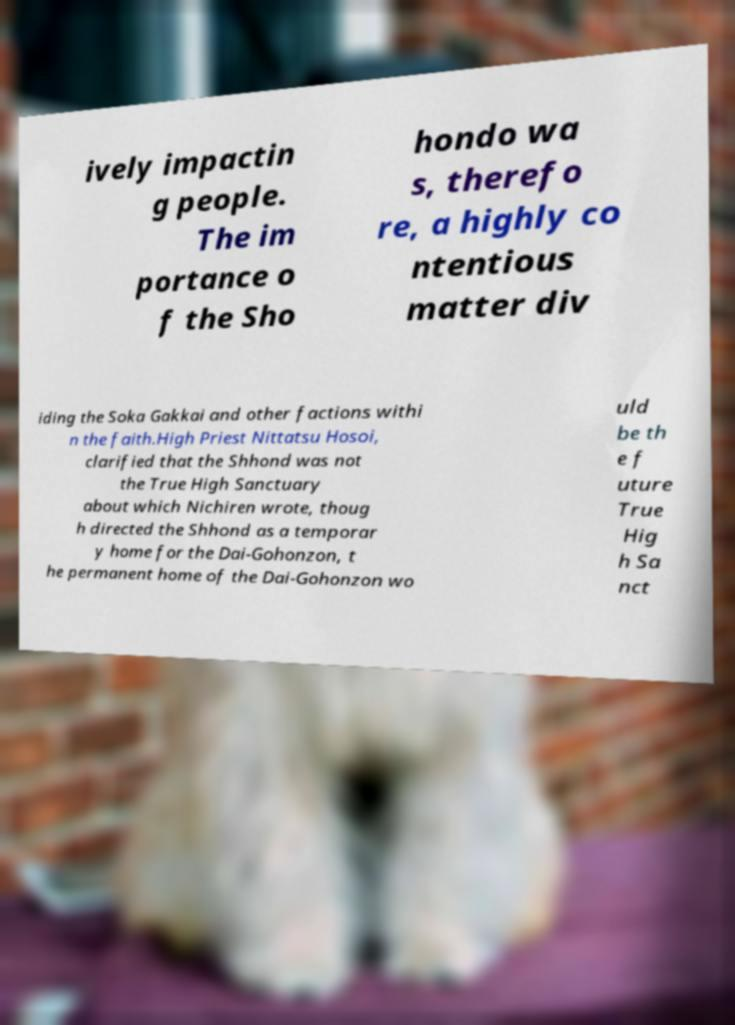Please read and relay the text visible in this image. What does it say? ively impactin g people. The im portance o f the Sho hondo wa s, therefo re, a highly co ntentious matter div iding the Soka Gakkai and other factions withi n the faith.High Priest Nittatsu Hosoi, clarified that the Shhond was not the True High Sanctuary about which Nichiren wrote, thoug h directed the Shhond as a temporar y home for the Dai-Gohonzon, t he permanent home of the Dai-Gohonzon wo uld be th e f uture True Hig h Sa nct 